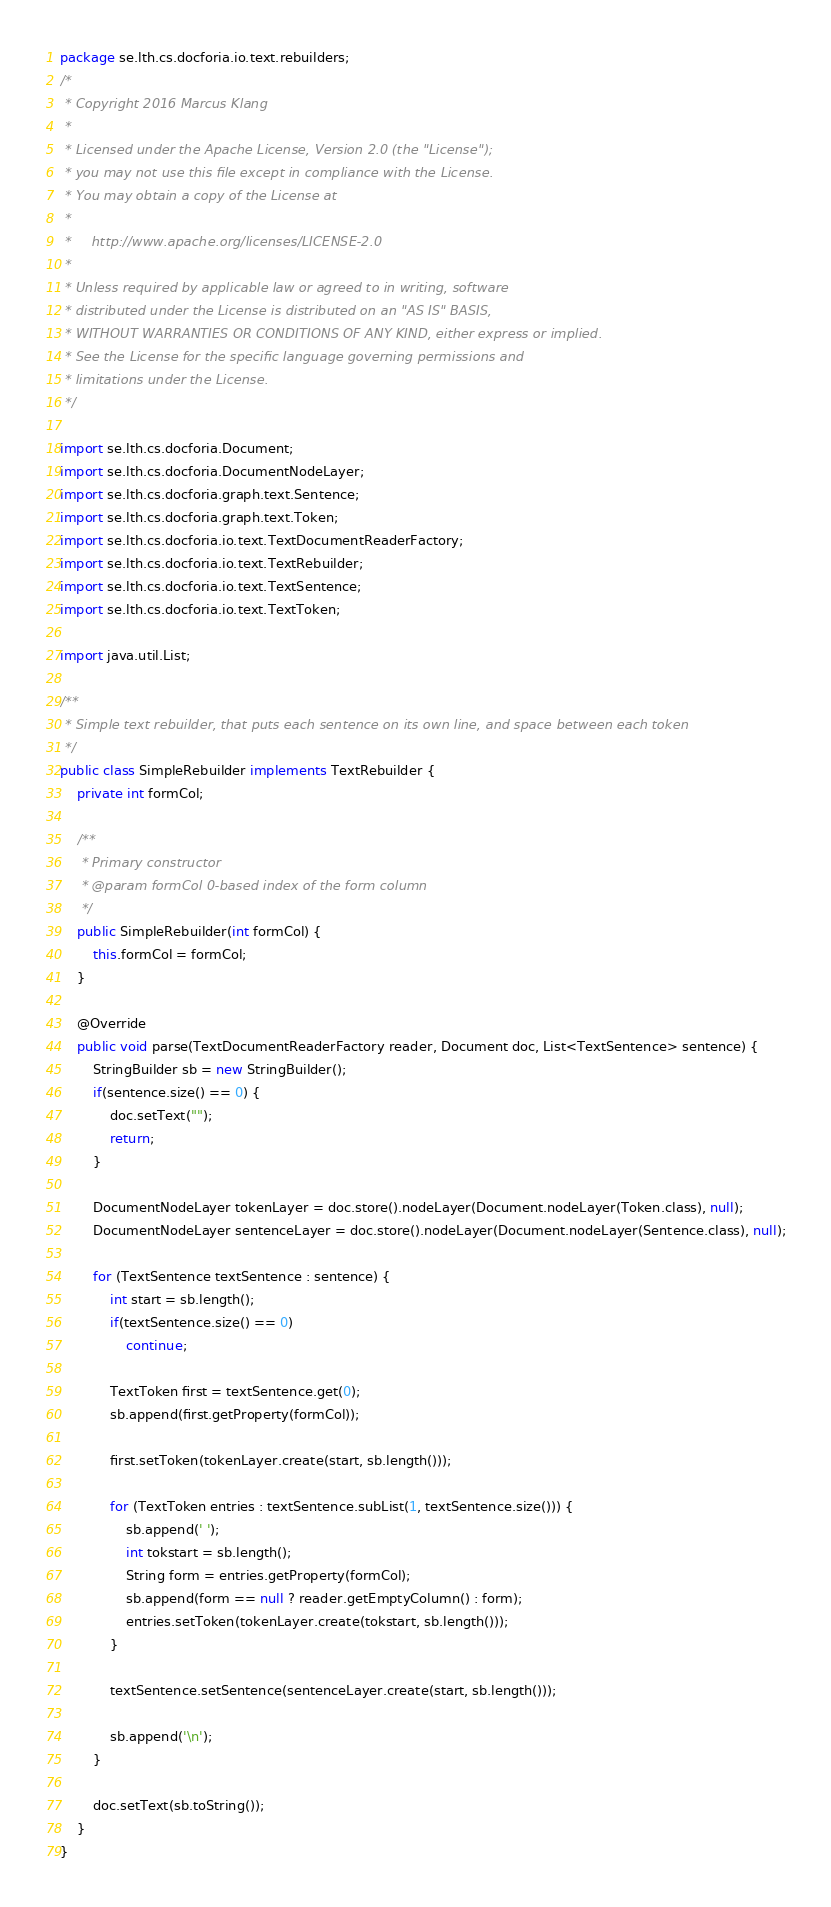<code> <loc_0><loc_0><loc_500><loc_500><_Java_>package se.lth.cs.docforia.io.text.rebuilders;
/*
 * Copyright 2016 Marcus Klang
 *
 * Licensed under the Apache License, Version 2.0 (the "License");
 * you may not use this file except in compliance with the License.
 * You may obtain a copy of the License at
 *
 *     http://www.apache.org/licenses/LICENSE-2.0
 *
 * Unless required by applicable law or agreed to in writing, software
 * distributed under the License is distributed on an "AS IS" BASIS,
 * WITHOUT WARRANTIES OR CONDITIONS OF ANY KIND, either express or implied.
 * See the License for the specific language governing permissions and
 * limitations under the License.
 */

import se.lth.cs.docforia.Document;
import se.lth.cs.docforia.DocumentNodeLayer;
import se.lth.cs.docforia.graph.text.Sentence;
import se.lth.cs.docforia.graph.text.Token;
import se.lth.cs.docforia.io.text.TextDocumentReaderFactory;
import se.lth.cs.docforia.io.text.TextRebuilder;
import se.lth.cs.docforia.io.text.TextSentence;
import se.lth.cs.docforia.io.text.TextToken;

import java.util.List;

/**
 * Simple text rebuilder, that puts each sentence on its own line, and space between each token
 */
public class SimpleRebuilder implements TextRebuilder {
    private int formCol;

    /**
     * Primary constructor
     * @param formCol 0-based index of the form column
     */
    public SimpleRebuilder(int formCol) {
        this.formCol = formCol;
    }

    @Override
    public void parse(TextDocumentReaderFactory reader, Document doc, List<TextSentence> sentence) {
        StringBuilder sb = new StringBuilder();
        if(sentence.size() == 0) {
            doc.setText("");
            return;
        }

        DocumentNodeLayer tokenLayer = doc.store().nodeLayer(Document.nodeLayer(Token.class), null);
        DocumentNodeLayer sentenceLayer = doc.store().nodeLayer(Document.nodeLayer(Sentence.class), null);

        for (TextSentence textSentence : sentence) {
            int start = sb.length();
            if(textSentence.size() == 0)
                continue;

            TextToken first = textSentence.get(0);
            sb.append(first.getProperty(formCol));

            first.setToken(tokenLayer.create(start, sb.length()));

            for (TextToken entries : textSentence.subList(1, textSentence.size())) {
                sb.append(' ');
                int tokstart = sb.length();
                String form = entries.getProperty(formCol);
                sb.append(form == null ? reader.getEmptyColumn() : form);
                entries.setToken(tokenLayer.create(tokstart, sb.length()));
            }

            textSentence.setSentence(sentenceLayer.create(start, sb.length()));

            sb.append('\n');
        }

        doc.setText(sb.toString());
    }
}
</code> 